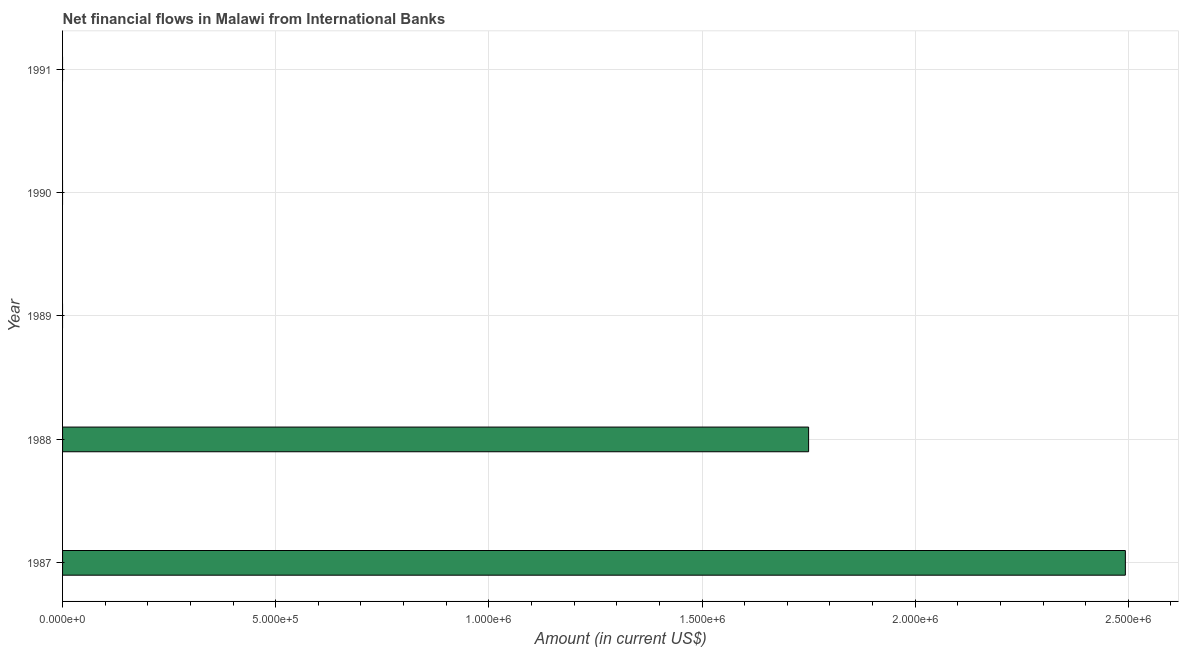Does the graph contain any zero values?
Your answer should be compact. Yes. Does the graph contain grids?
Keep it short and to the point. Yes. What is the title of the graph?
Offer a terse response. Net financial flows in Malawi from International Banks. What is the net financial flows from ibrd in 1988?
Ensure brevity in your answer.  1.75e+06. Across all years, what is the maximum net financial flows from ibrd?
Make the answer very short. 2.49e+06. Across all years, what is the minimum net financial flows from ibrd?
Provide a succinct answer. 0. What is the sum of the net financial flows from ibrd?
Your response must be concise. 4.24e+06. What is the difference between the net financial flows from ibrd in 1987 and 1988?
Your answer should be very brief. 7.43e+05. What is the average net financial flows from ibrd per year?
Your response must be concise. 8.49e+05. What is the median net financial flows from ibrd?
Make the answer very short. 0. Is the net financial flows from ibrd in 1987 less than that in 1988?
Offer a very short reply. No. Is the difference between the net financial flows from ibrd in 1987 and 1988 greater than the difference between any two years?
Offer a very short reply. No. What is the difference between the highest and the lowest net financial flows from ibrd?
Your answer should be compact. 2.49e+06. In how many years, is the net financial flows from ibrd greater than the average net financial flows from ibrd taken over all years?
Your answer should be compact. 2. How many years are there in the graph?
Make the answer very short. 5. What is the Amount (in current US$) in 1987?
Offer a very short reply. 2.49e+06. What is the Amount (in current US$) in 1988?
Provide a succinct answer. 1.75e+06. What is the Amount (in current US$) in 1989?
Provide a succinct answer. 0. What is the Amount (in current US$) in 1991?
Keep it short and to the point. 0. What is the difference between the Amount (in current US$) in 1987 and 1988?
Give a very brief answer. 7.43e+05. What is the ratio of the Amount (in current US$) in 1987 to that in 1988?
Offer a very short reply. 1.43. 